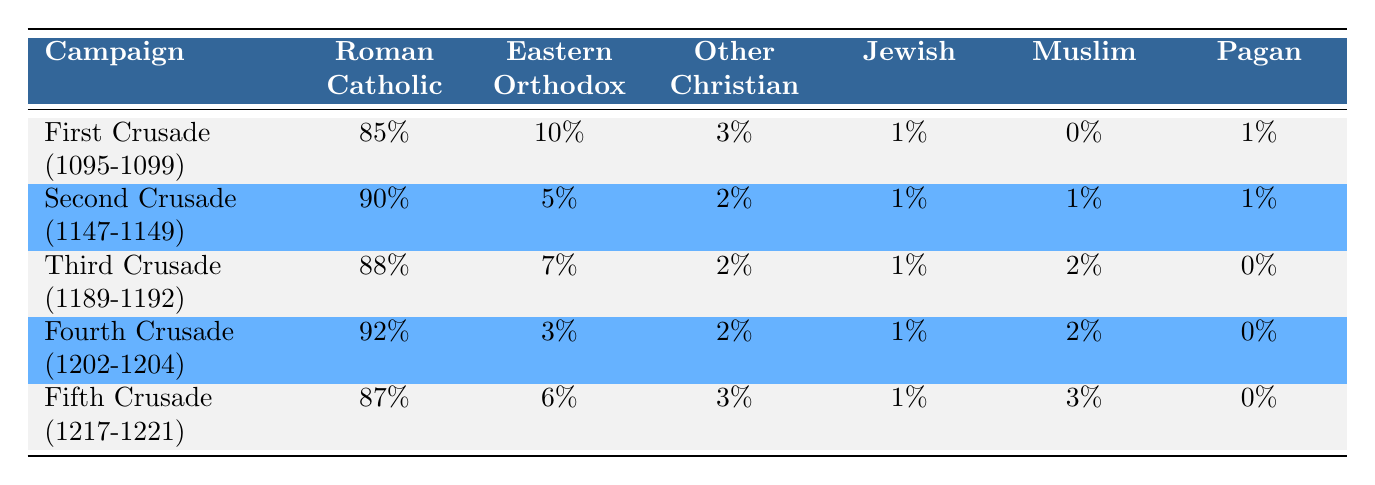What percentage of the First Crusade army was Roman Catholic? The table indicates that 85% of the First Crusade participants identified as Roman Catholic.
Answer: 85% Was there any representation of Muslims in the Second Crusade? The table shows that there was 1% representation of Muslims in the Second Crusade.
Answer: Yes Which campaign had the lowest percentage of Eastern Orthodox participants? Looking at the table, the Fourth Crusade had the lowest percentage of Eastern Orthodox participants, at 3%.
Answer: Fourth Crusade (1202-1204) Calculate the average percentage of Jewish participants across all campaigns. Adding the percentages of Jewish participants: 1% (First) + 1% (Second) + 1% (Third) + 1% (Fourth) + 1% (Fifth) = 5%. Then divide by the number of campaigns (5) to get the average: 5% / 5 = 1%.
Answer: 1% Were there any campaigns with no Pagan participants? By examining the table, we see that both the Third and Fourth Crusades had 0% Pagan participants.
Answer: Yes 